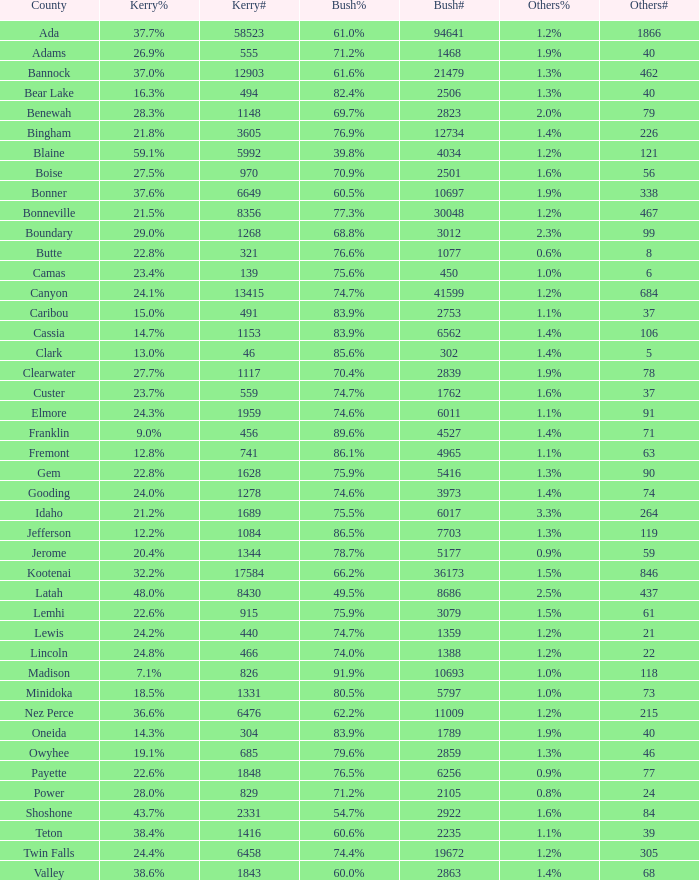What fraction of the votes in oneida did kerry achieve? 14.3%. 